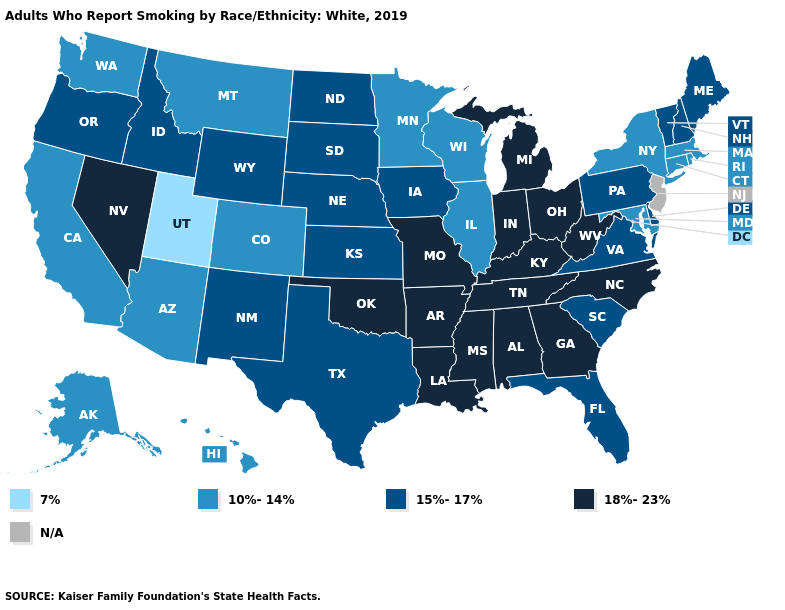What is the value of Wisconsin?
Write a very short answer. 10%-14%. What is the value of Utah?
Write a very short answer. 7%. Name the states that have a value in the range 7%?
Keep it brief. Utah. What is the highest value in the USA?
Give a very brief answer. 18%-23%. Among the states that border Pennsylvania , which have the highest value?
Short answer required. Ohio, West Virginia. Name the states that have a value in the range 10%-14%?
Concise answer only. Alaska, Arizona, California, Colorado, Connecticut, Hawaii, Illinois, Maryland, Massachusetts, Minnesota, Montana, New York, Rhode Island, Washington, Wisconsin. Among the states that border Oregon , does Washington have the lowest value?
Answer briefly. Yes. Among the states that border Indiana , which have the highest value?
Answer briefly. Kentucky, Michigan, Ohio. Name the states that have a value in the range 15%-17%?
Answer briefly. Delaware, Florida, Idaho, Iowa, Kansas, Maine, Nebraska, New Hampshire, New Mexico, North Dakota, Oregon, Pennsylvania, South Carolina, South Dakota, Texas, Vermont, Virginia, Wyoming. What is the value of Arkansas?
Quick response, please. 18%-23%. Among the states that border Iowa , does Nebraska have the lowest value?
Write a very short answer. No. How many symbols are there in the legend?
Short answer required. 5. What is the value of Nebraska?
Be succinct. 15%-17%. What is the value of Oregon?
Give a very brief answer. 15%-17%. 